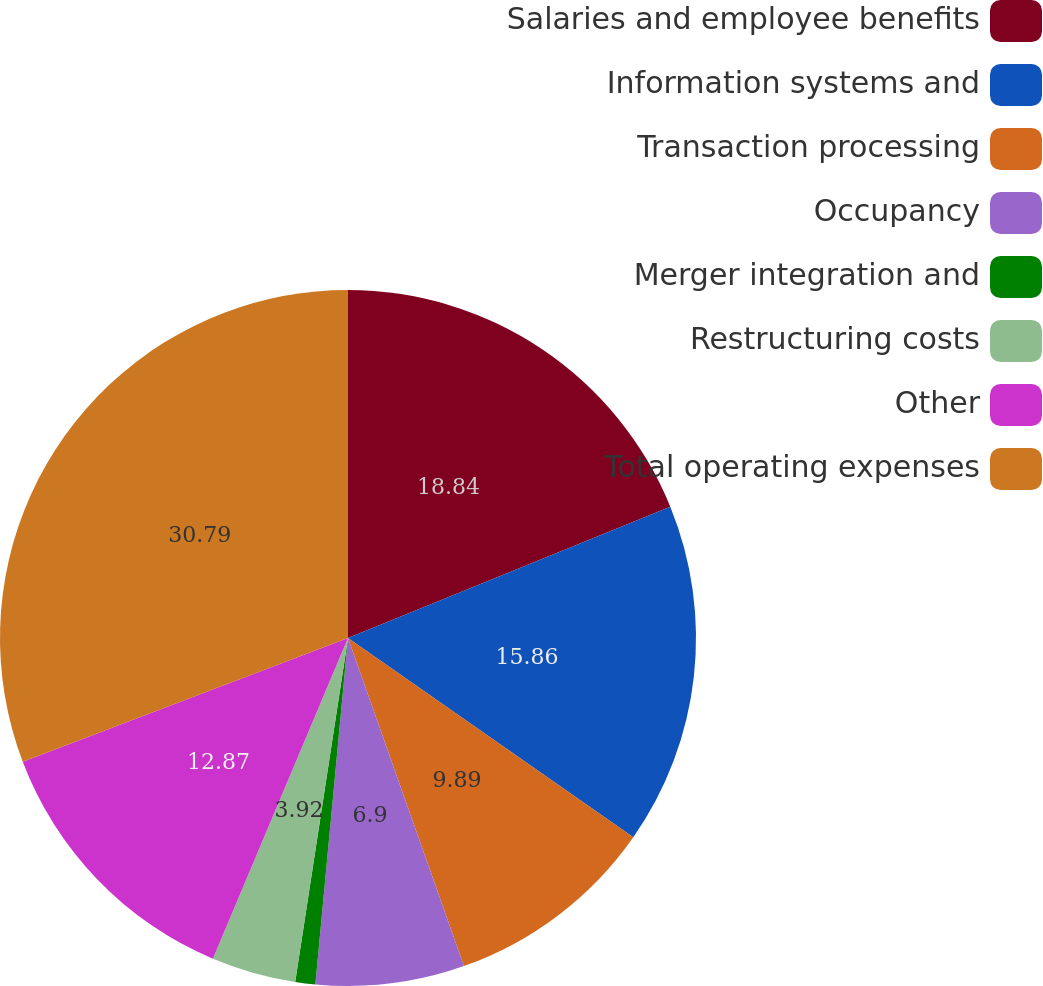Convert chart to OTSL. <chart><loc_0><loc_0><loc_500><loc_500><pie_chart><fcel>Salaries and employee benefits<fcel>Information systems and<fcel>Transaction processing<fcel>Occupancy<fcel>Merger integration and<fcel>Restructuring costs<fcel>Other<fcel>Total operating expenses<nl><fcel>18.84%<fcel>15.86%<fcel>9.89%<fcel>6.9%<fcel>0.93%<fcel>3.92%<fcel>12.87%<fcel>30.78%<nl></chart> 